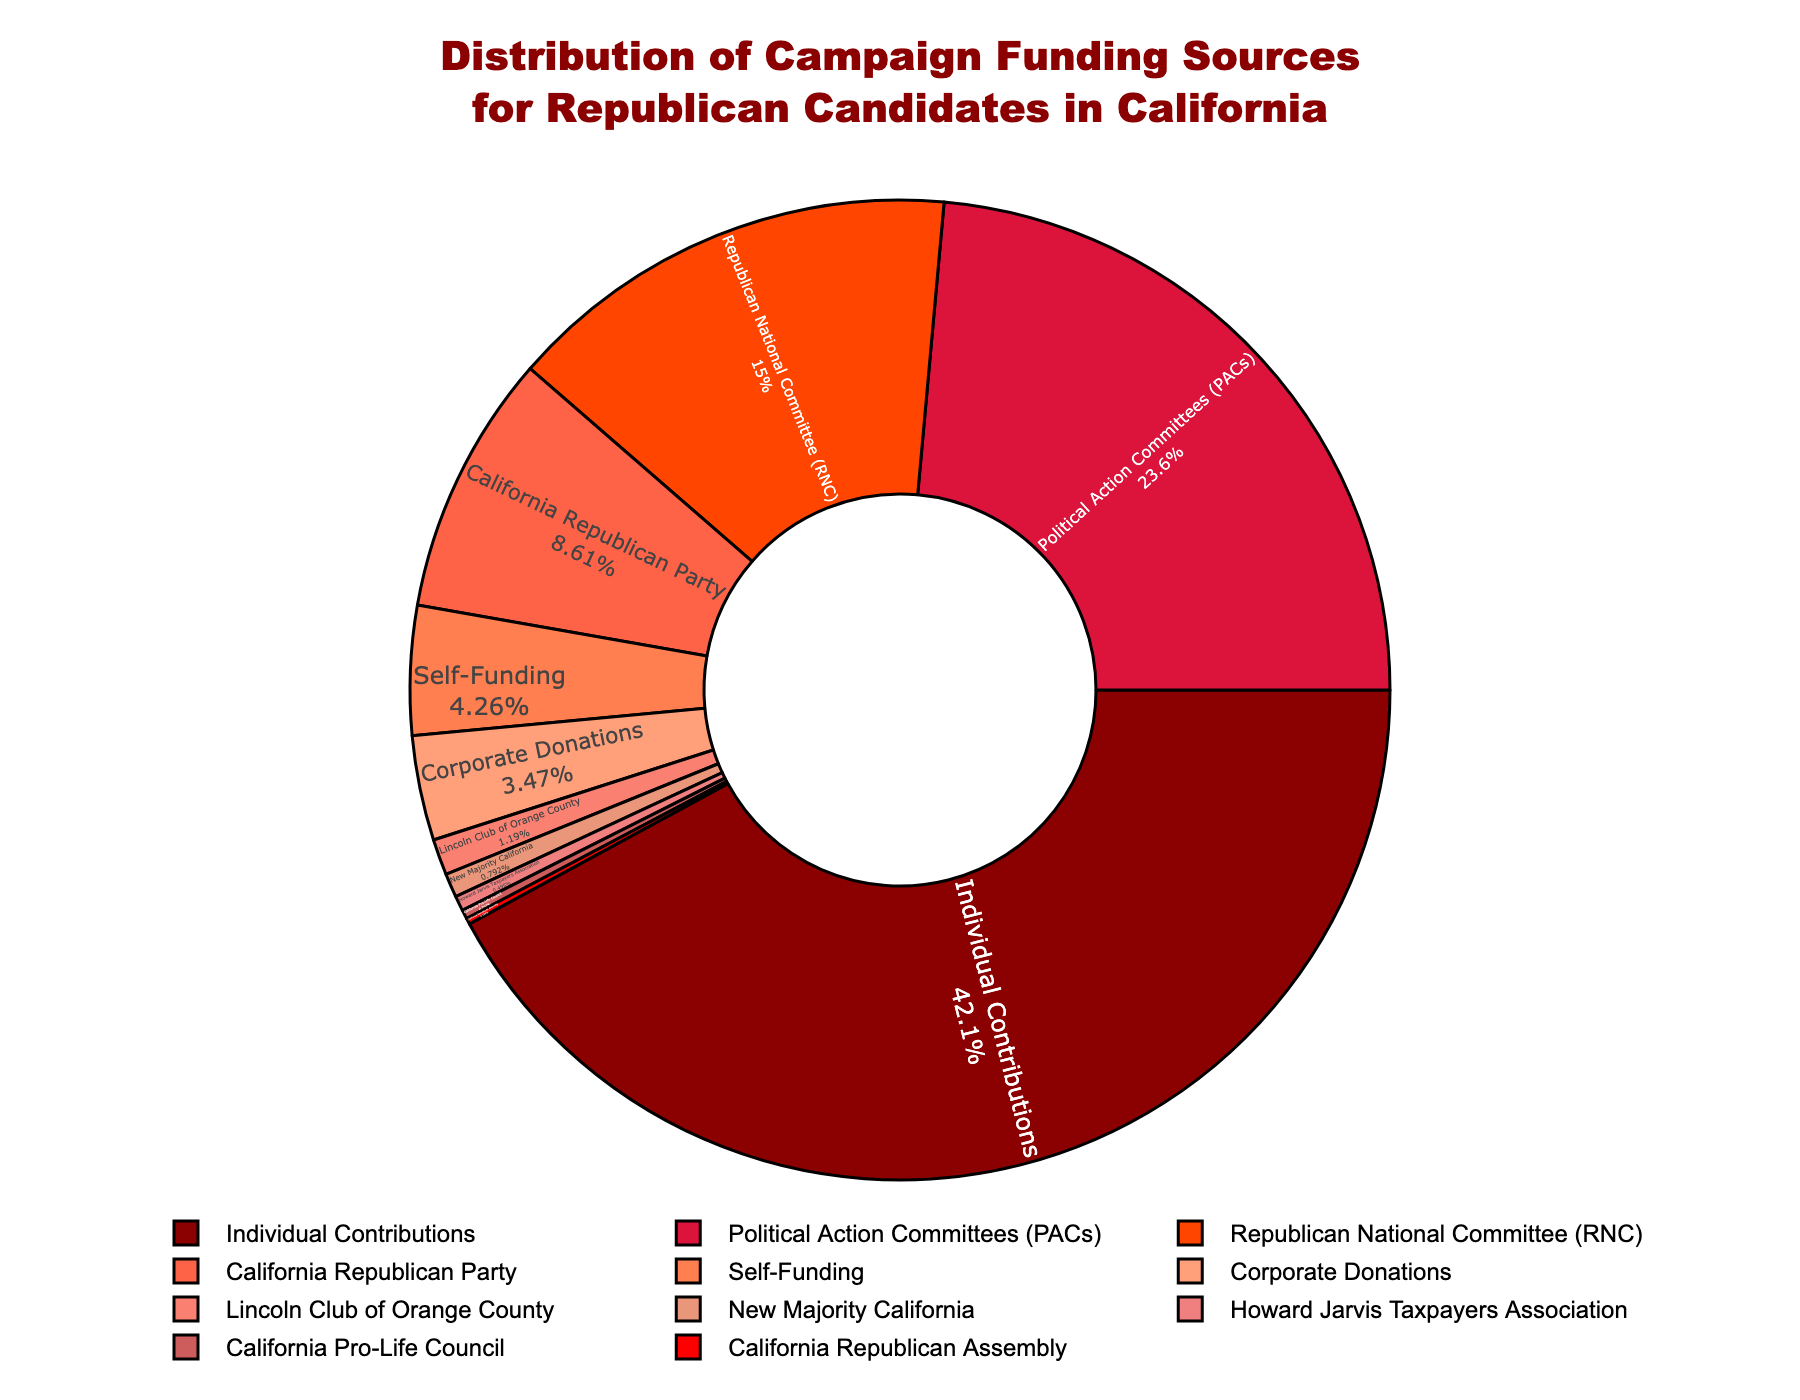What's the source with the largest percentage of campaign funding? The largest percentage segment in the pie chart is labeled "Individual Contributions," which stands out visually as the biggest part of the pie.
Answer: Individual Contributions What's the total percentage of funding from Political Action Committees (PACs) and the Republican National Committee (RNC)? Add the percentages of PACs (23.8) and RNC (15.2). So, 23.8 + 15.2 = 39.
Answer: 39 Which source contributes more, Corporate Donations or Self-Funding? The pie chart shows Self-Funding at 4.3% and Corporate Donations at 3.5%, meaning Self-Funding is greater.
Answer: Self-Funding What is the visual color for Individual Contributions? The pie chart has Individual Contributions marked in dark red, located as the largest segment.
Answer: Red By how much do contributions from Political Action Committees (PACs) exceed those from the California Republican Party? Subtract the percentage of the California Republican Party (8.7) from PACs (23.8). So 23.8 - 8.7 = 15.1.
Answer: 15.1 What is the combined percentage of the smallest three funding sources? The smallest three segments are California Republican Assembly (0.2), California Pro-Life Council (0.3), and Howard Jarvis Taxpayers Association (0.5). Sum them up: 0.2 + 0.3 + 0.5 = 1.
Answer: 1 Are the contributions from the Lincoln Club of Orange County greater or less than 2%? The pie chart shows the Lincoln Club of Orange County segment as 1.2%, which is less than 2%.
Answer: Less What percentage of campaign funding does the California Republican Party contribute? The pie chart displays the label "California Republican Party" with a percentage of 8.7.
Answer: 8.7 How does the funding from New Majority California compare to the Howard Jarvis Taxpayers Association? New Majority California contributes 0.8%, while Howard Jarvis Taxpayers Association contributes 0.5%, making New Majority California greater.
Answer: New Majority California What is the difference between the largest and smallest funding sources? The largest is Individual Contributions at 42.5% and the smallest is California Republican Assembly at 0.2%. Subtract to find the difference: 42.5 - 0.2 = 42.3.
Answer: 42.3 